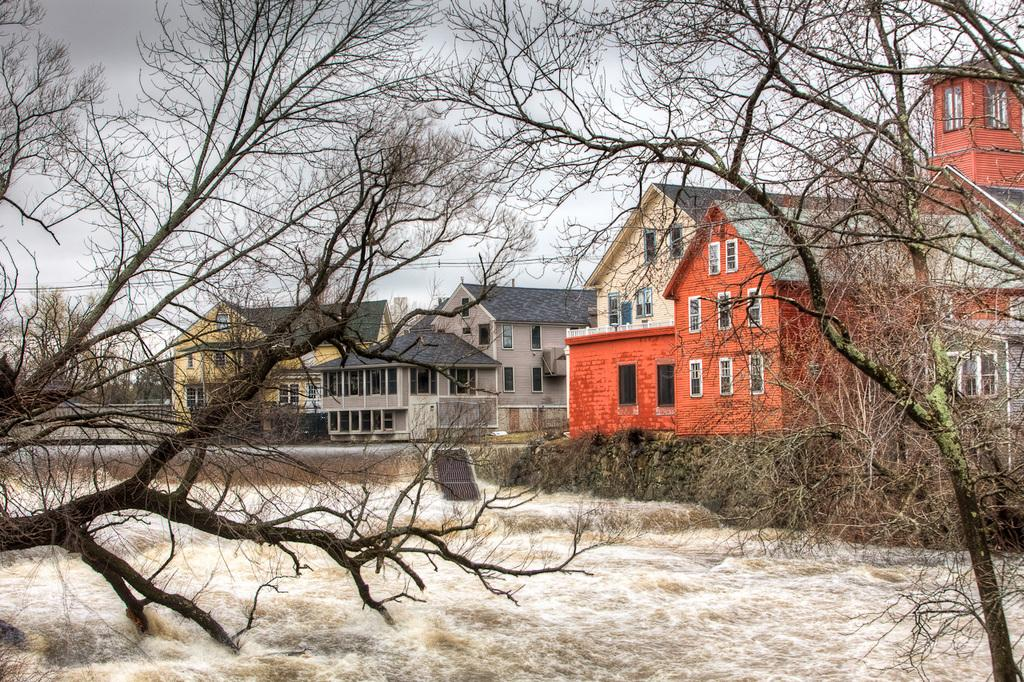What type of natural environment is visible in the background of the image? There are houses in the background of the image, suggesting a residential area. What is the main feature in the center of the image? There is water in the center of the image. What type of vegetation is in the foreground of the image? There are trees in the foreground of the image. What is the price of the art displayed on the water in the image? There is no art displayed on the water in the image, so it is not possible to determine its price. What type of nut can be seen growing on the trees in the foreground of the image? There is no mention of nuts in the provided facts, and the image does not show any nuts growing on the trees. 